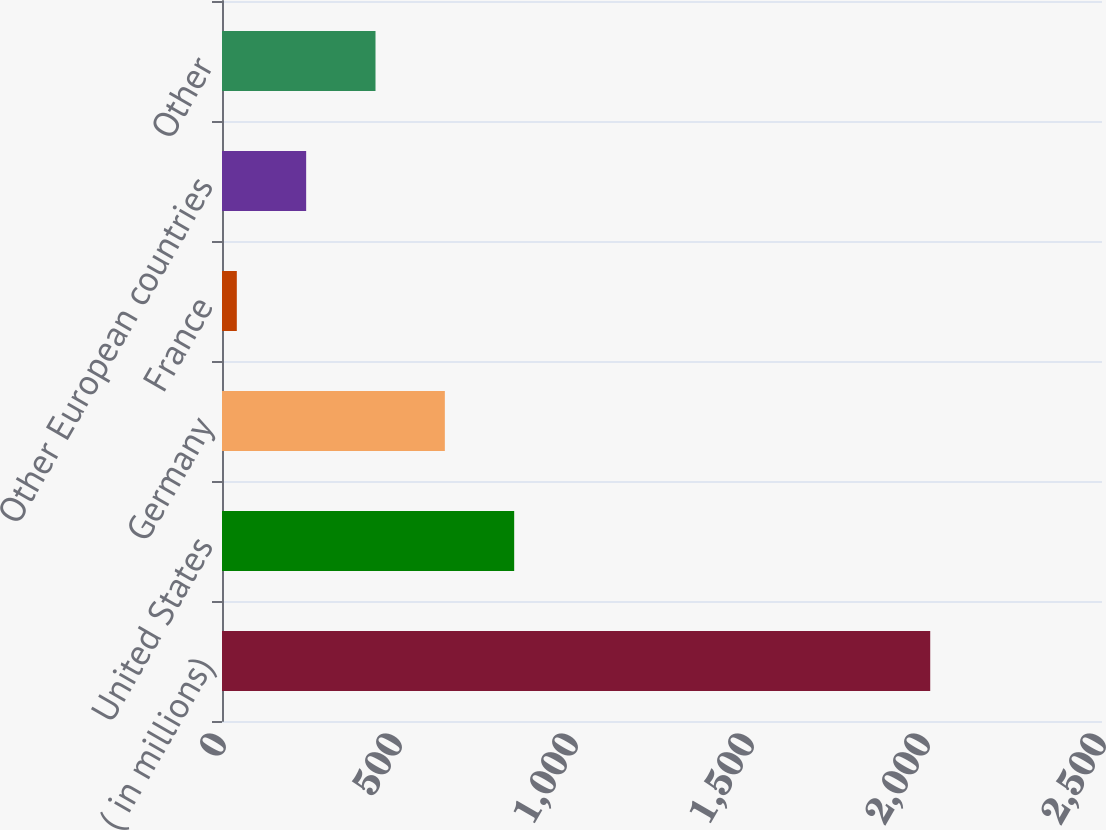Convert chart to OTSL. <chart><loc_0><loc_0><loc_500><loc_500><bar_chart><fcel>( in millions)<fcel>United States<fcel>Germany<fcel>France<fcel>Other European countries<fcel>Other<nl><fcel>2012<fcel>830.06<fcel>633.07<fcel>42.1<fcel>239.09<fcel>436.08<nl></chart> 